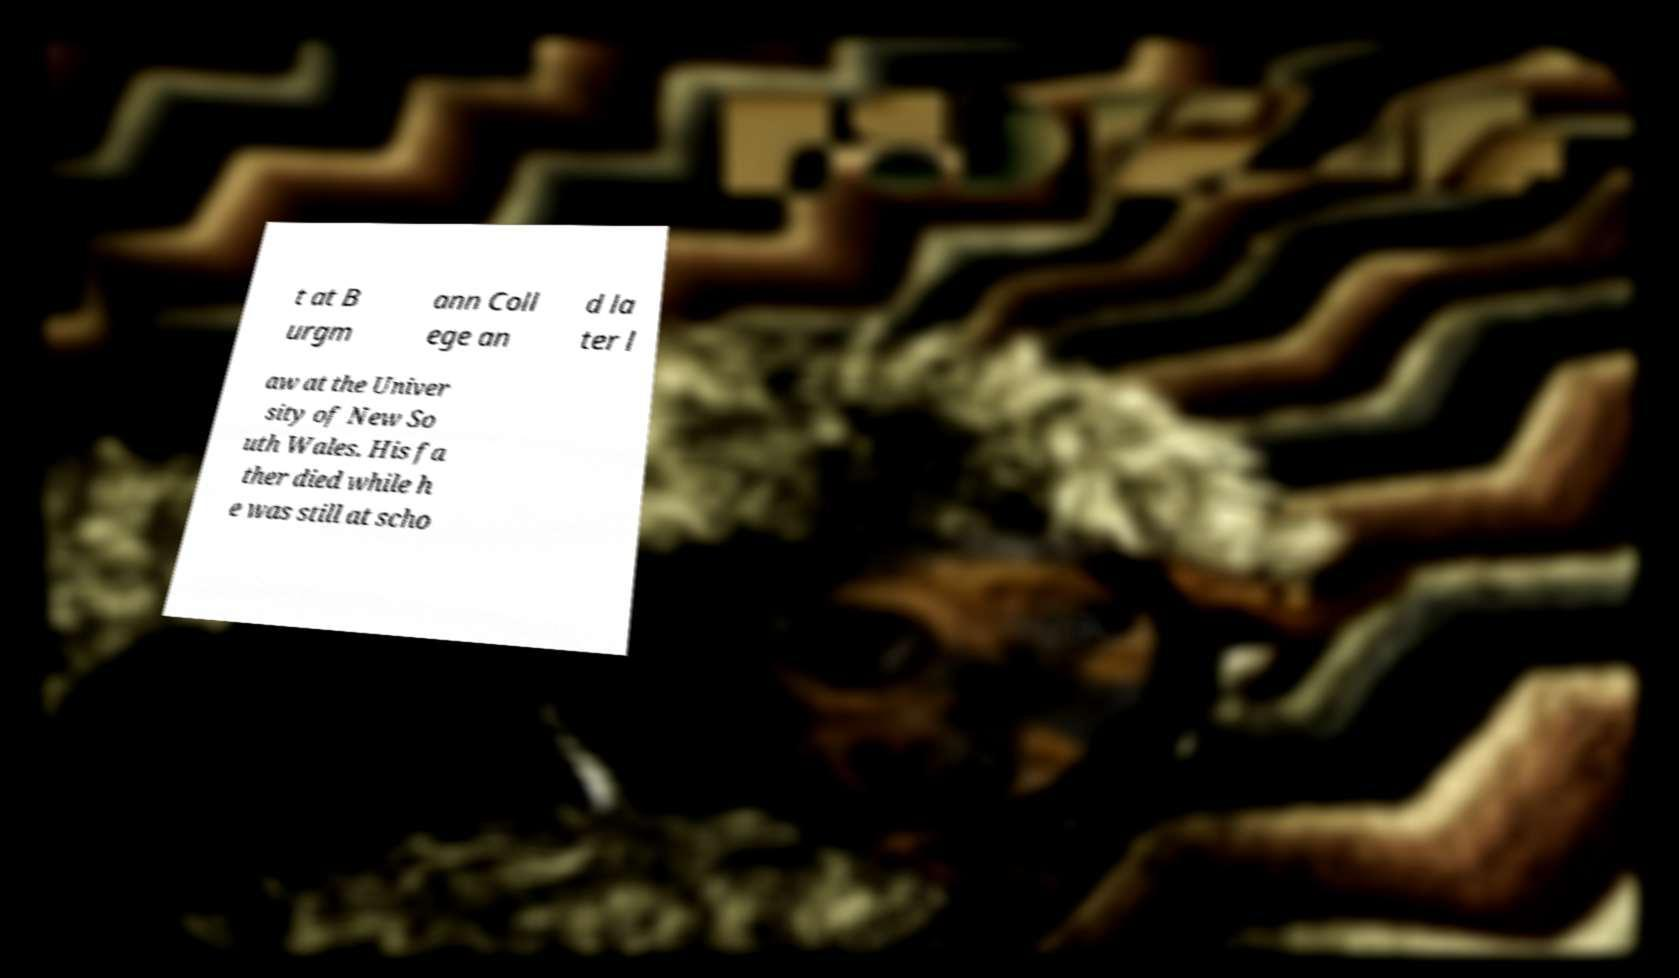Could you extract and type out the text from this image? t at B urgm ann Coll ege an d la ter l aw at the Univer sity of New So uth Wales. His fa ther died while h e was still at scho 